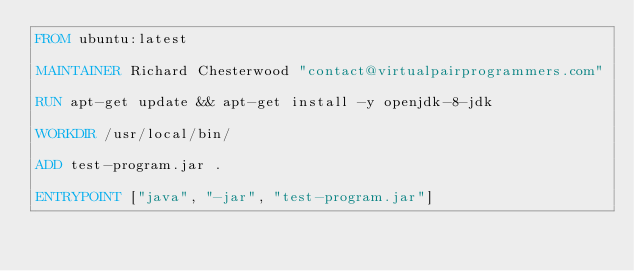Convert code to text. <code><loc_0><loc_0><loc_500><loc_500><_Dockerfile_>FROM ubuntu:latest

MAINTAINER Richard Chesterwood "contact@virtualpairprogrammers.com"

RUN apt-get update && apt-get install -y openjdk-8-jdk

WORKDIR /usr/local/bin/

ADD test-program.jar .

ENTRYPOINT ["java", "-jar", "test-program.jar"]
</code> 